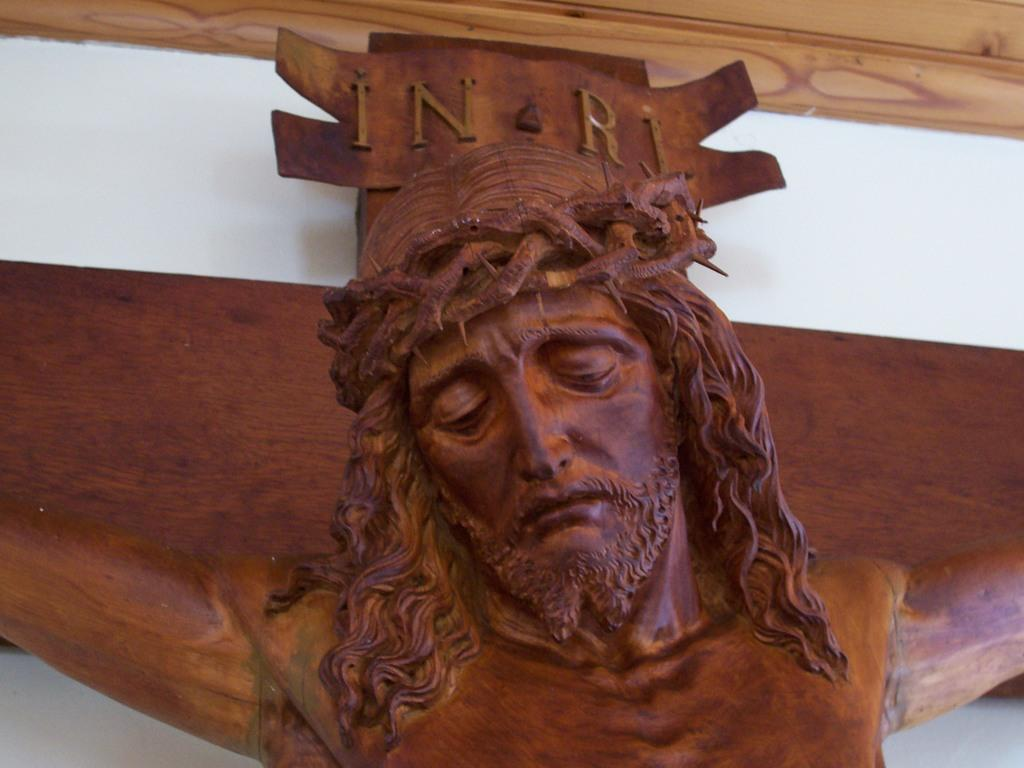What type of object can be seen in the image? There is a wooden statue in the image. Where is the wooden statue located? The wooden statue is on the wall. How does the wooden statue express anger in the image? The wooden statue does not express anger in the image, as it is an inanimate object and cannot display emotions. 